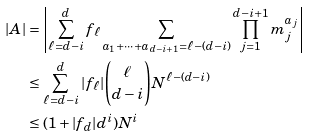Convert formula to latex. <formula><loc_0><loc_0><loc_500><loc_500>| A | & = \left | \sum _ { \ell = d - i } ^ { d } f _ { \ell } \sum _ { a _ { 1 } + \cdots + a _ { d - i + 1 } = \ell - ( d - i ) } \prod _ { j = 1 } ^ { d - i + 1 } m _ { j } ^ { a _ { j } } \right | \\ & \leq \sum _ { \ell = d - i } ^ { d } | f _ { \ell } | \binom { \ell } { d - i } N ^ { \ell - ( d - i ) } \\ & \leq ( 1 + | f _ { d } | d ^ { i } ) N ^ { i }</formula> 